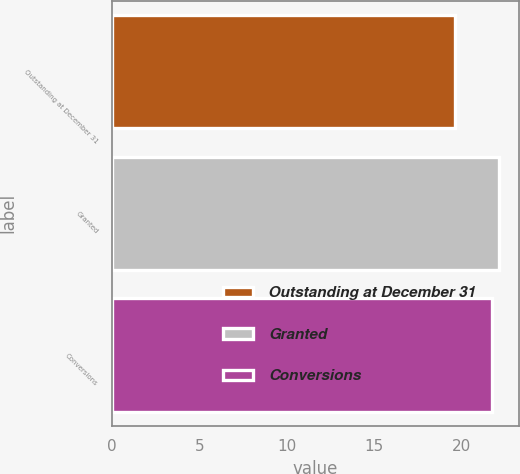<chart> <loc_0><loc_0><loc_500><loc_500><bar_chart><fcel>Outstanding at December 31<fcel>Granted<fcel>Conversions<nl><fcel>19.63<fcel>22.18<fcel>21.77<nl></chart> 